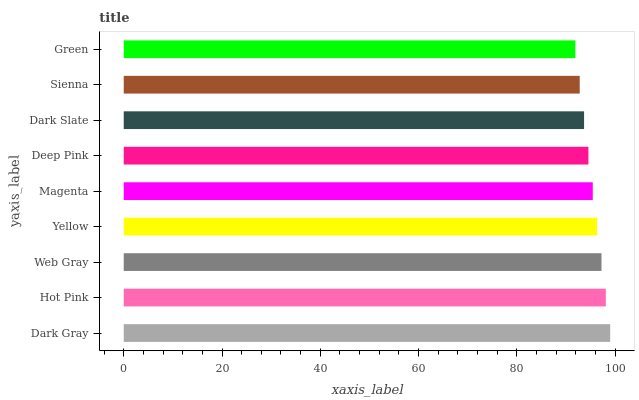Is Green the minimum?
Answer yes or no. Yes. Is Dark Gray the maximum?
Answer yes or no. Yes. Is Hot Pink the minimum?
Answer yes or no. No. Is Hot Pink the maximum?
Answer yes or no. No. Is Dark Gray greater than Hot Pink?
Answer yes or no. Yes. Is Hot Pink less than Dark Gray?
Answer yes or no. Yes. Is Hot Pink greater than Dark Gray?
Answer yes or no. No. Is Dark Gray less than Hot Pink?
Answer yes or no. No. Is Magenta the high median?
Answer yes or no. Yes. Is Magenta the low median?
Answer yes or no. Yes. Is Dark Slate the high median?
Answer yes or no. No. Is Hot Pink the low median?
Answer yes or no. No. 